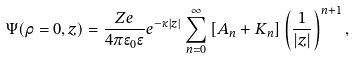Convert formula to latex. <formula><loc_0><loc_0><loc_500><loc_500>\Psi ( \rho = 0 , z ) = \frac { Z e } { 4 \pi \epsilon _ { 0 } \epsilon } e ^ { - \kappa | z | } \sum _ { n = 0 } ^ { \infty } \left [ A _ { n } + K _ { n } \right ] \left ( \frac { 1 } { | z | } \right ) ^ { n + 1 } ,</formula> 